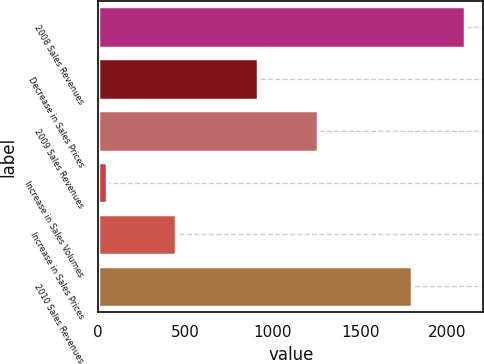Convert chart. <chart><loc_0><loc_0><loc_500><loc_500><bar_chart><fcel>2008 Sales Revenues<fcel>Decrease in Sales Prices<fcel>2009 Sales Revenues<fcel>Increase in Sales Volumes<fcel>Increase in Sales Prices<fcel>2010 Sales Revenues<nl><fcel>2101<fcel>915<fcel>1261<fcel>48<fcel>447<fcel>1795<nl></chart> 